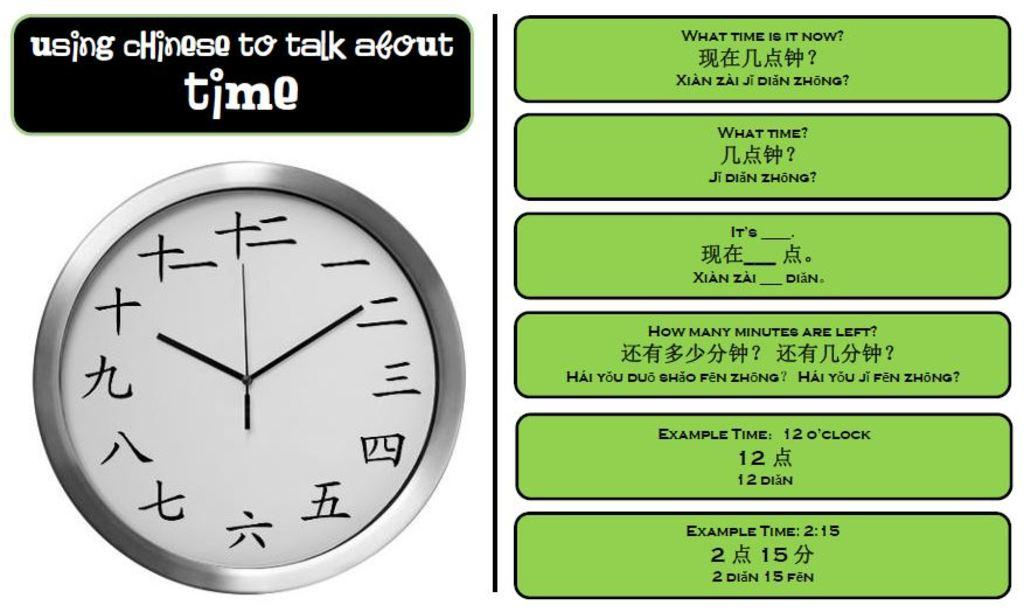<image>
Offer a succinct explanation of the picture presented. The text suggests this is an info-graphic on how to ask about the time in Chinese. 